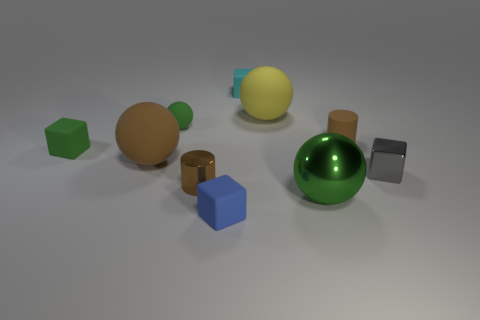Do the metal cylinder and the tiny matte cylinder have the same color?
Offer a very short reply. Yes. There is a brown cylinder in front of the green rubber object that is in front of the tiny brown matte cylinder; what size is it?
Offer a very short reply. Small. The large metallic thing in front of the block behind the matte cylinder to the left of the tiny gray metallic block is what shape?
Offer a terse response. Sphere. There is a yellow thing that is the same material as the large brown thing; what is its size?
Offer a very short reply. Large. Are there more green objects than objects?
Give a very brief answer. No. There is a green ball that is the same size as the yellow ball; what is its material?
Offer a terse response. Metal. Does the green object to the right of the shiny cylinder have the same size as the small gray object?
Offer a very short reply. No. How many cylinders are either gray shiny things or brown things?
Provide a short and direct response. 2. What is the tiny cylinder that is in front of the gray shiny object made of?
Offer a terse response. Metal. Are there fewer large things than small blue rubber blocks?
Your answer should be very brief. No. 